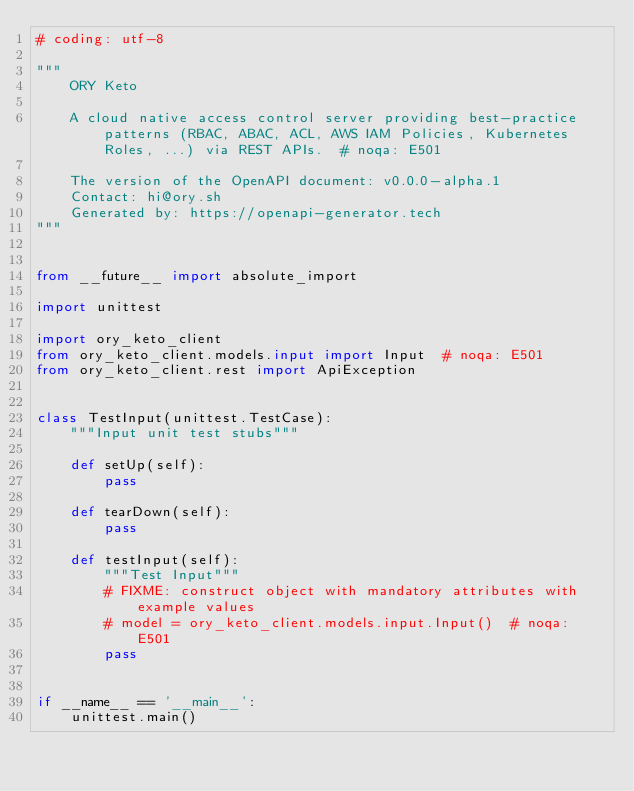Convert code to text. <code><loc_0><loc_0><loc_500><loc_500><_Python_># coding: utf-8

"""
    ORY Keto

    A cloud native access control server providing best-practice patterns (RBAC, ABAC, ACL, AWS IAM Policies, Kubernetes Roles, ...) via REST APIs.  # noqa: E501

    The version of the OpenAPI document: v0.0.0-alpha.1
    Contact: hi@ory.sh
    Generated by: https://openapi-generator.tech
"""


from __future__ import absolute_import

import unittest

import ory_keto_client
from ory_keto_client.models.input import Input  # noqa: E501
from ory_keto_client.rest import ApiException


class TestInput(unittest.TestCase):
    """Input unit test stubs"""

    def setUp(self):
        pass

    def tearDown(self):
        pass

    def testInput(self):
        """Test Input"""
        # FIXME: construct object with mandatory attributes with example values
        # model = ory_keto_client.models.input.Input()  # noqa: E501
        pass


if __name__ == '__main__':
    unittest.main()
</code> 